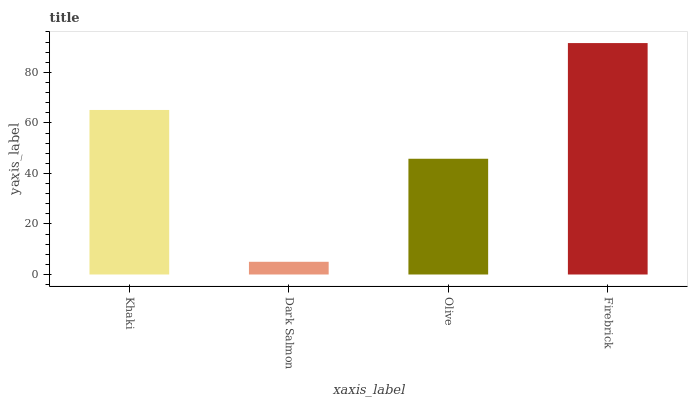Is Dark Salmon the minimum?
Answer yes or no. Yes. Is Firebrick the maximum?
Answer yes or no. Yes. Is Olive the minimum?
Answer yes or no. No. Is Olive the maximum?
Answer yes or no. No. Is Olive greater than Dark Salmon?
Answer yes or no. Yes. Is Dark Salmon less than Olive?
Answer yes or no. Yes. Is Dark Salmon greater than Olive?
Answer yes or no. No. Is Olive less than Dark Salmon?
Answer yes or no. No. Is Khaki the high median?
Answer yes or no. Yes. Is Olive the low median?
Answer yes or no. Yes. Is Olive the high median?
Answer yes or no. No. Is Khaki the low median?
Answer yes or no. No. 